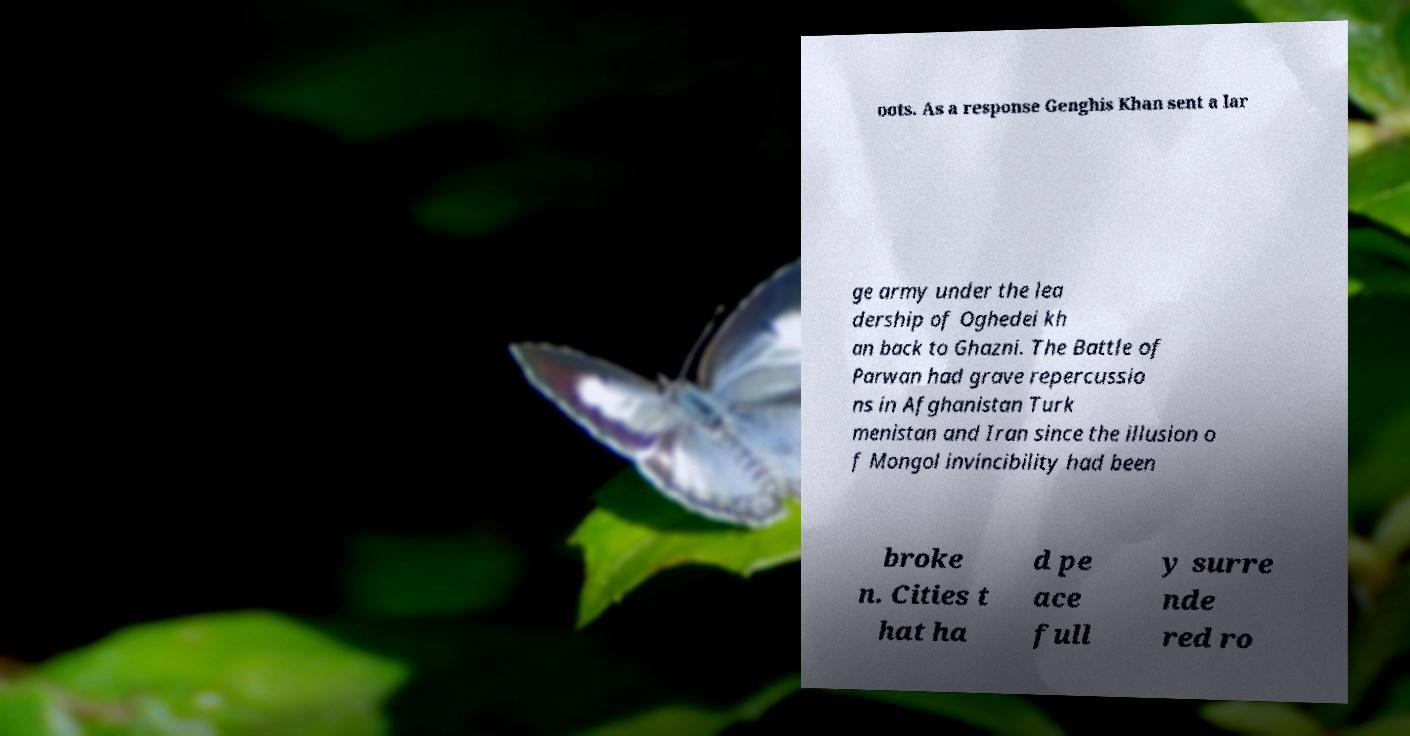Can you accurately transcribe the text from the provided image for me? oots. As a response Genghis Khan sent a lar ge army under the lea dership of Oghedei kh an back to Ghazni. The Battle of Parwan had grave repercussio ns in Afghanistan Turk menistan and Iran since the illusion o f Mongol invincibility had been broke n. Cities t hat ha d pe ace full y surre nde red ro 